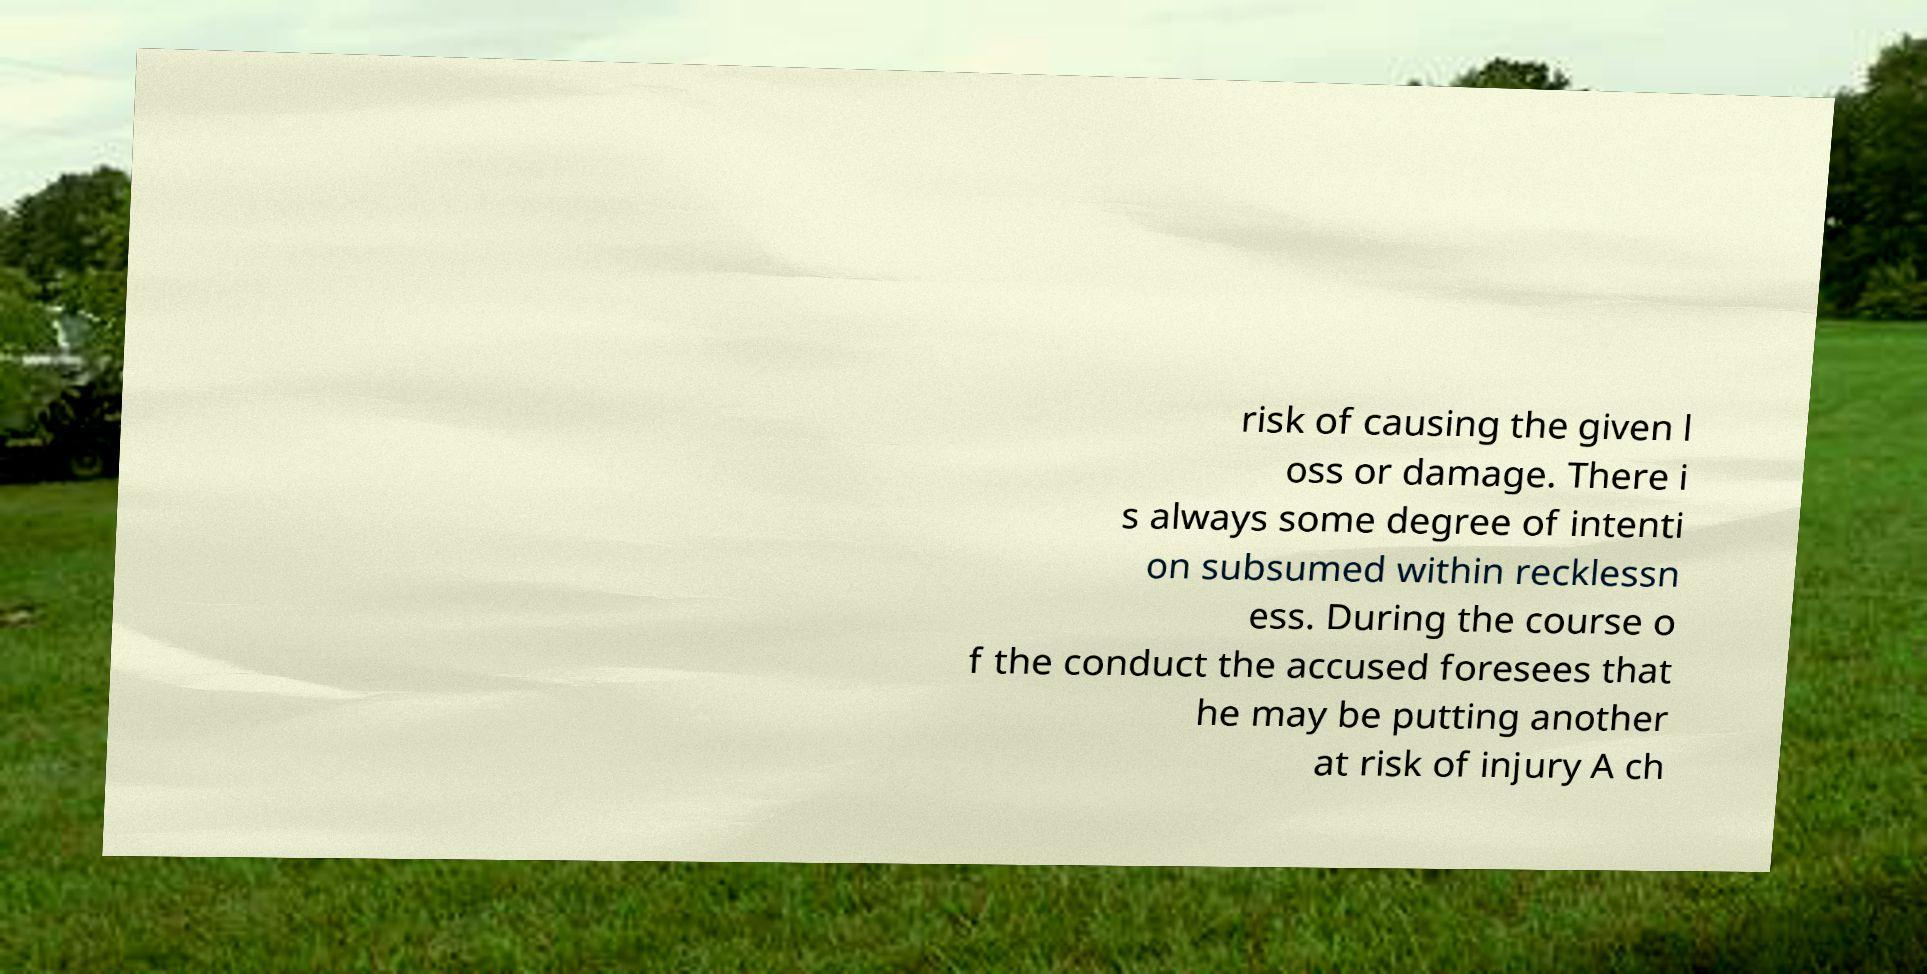I need the written content from this picture converted into text. Can you do that? risk of causing the given l oss or damage. There i s always some degree of intenti on subsumed within recklessn ess. During the course o f the conduct the accused foresees that he may be putting another at risk of injury A ch 